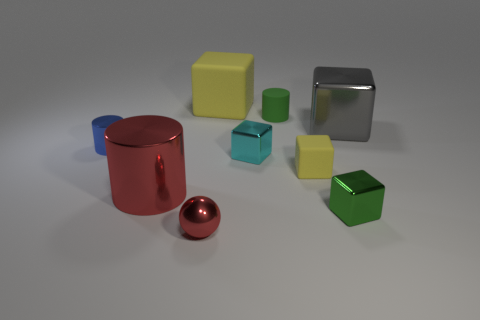What is the color of the cylinder that is made of the same material as the big yellow cube? green 